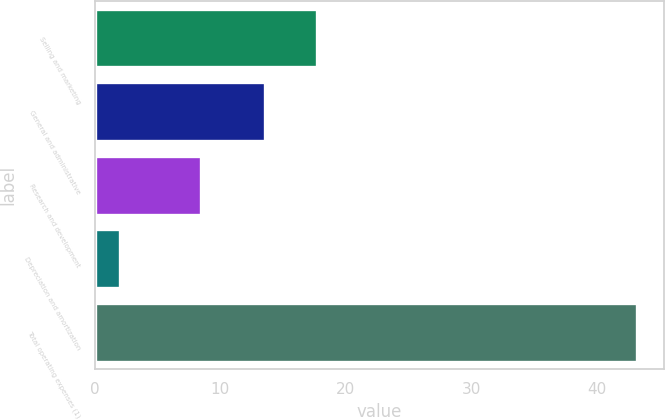<chart> <loc_0><loc_0><loc_500><loc_500><bar_chart><fcel>Selling and marketing<fcel>General and administrative<fcel>Research and development<fcel>Depreciation and amortization<fcel>Total operating expenses (1)<nl><fcel>17.72<fcel>13.6<fcel>8.5<fcel>2<fcel>43.2<nl></chart> 